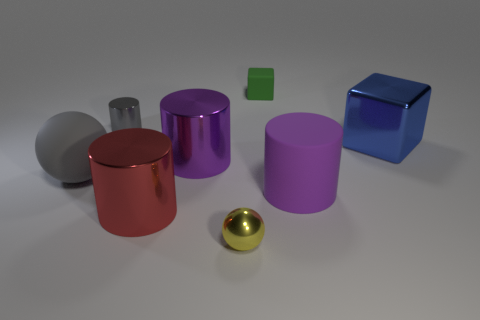Are there more large blue things that are behind the red shiny cylinder than tiny metal balls that are to the right of the big rubber cylinder?
Give a very brief answer. Yes. Are there any large gray rubber objects of the same shape as the yellow thing?
Your answer should be very brief. Yes. What shape is the green object that is the same size as the gray cylinder?
Give a very brief answer. Cube. There is a small object in front of the big ball; what is its shape?
Your response must be concise. Sphere. Are there fewer big blue metallic things that are on the left side of the big red cylinder than cubes on the right side of the large matte cylinder?
Provide a short and direct response. Yes. There is a gray rubber sphere; is its size the same as the purple thing to the right of the yellow sphere?
Give a very brief answer. Yes. What number of gray metallic cylinders have the same size as the green rubber thing?
Give a very brief answer. 1. There is a big block that is the same material as the small gray thing; what is its color?
Your answer should be compact. Blue. Are there more big purple metal objects than gray metal blocks?
Provide a succinct answer. Yes. Are the gray ball and the tiny gray cylinder made of the same material?
Provide a short and direct response. No. 